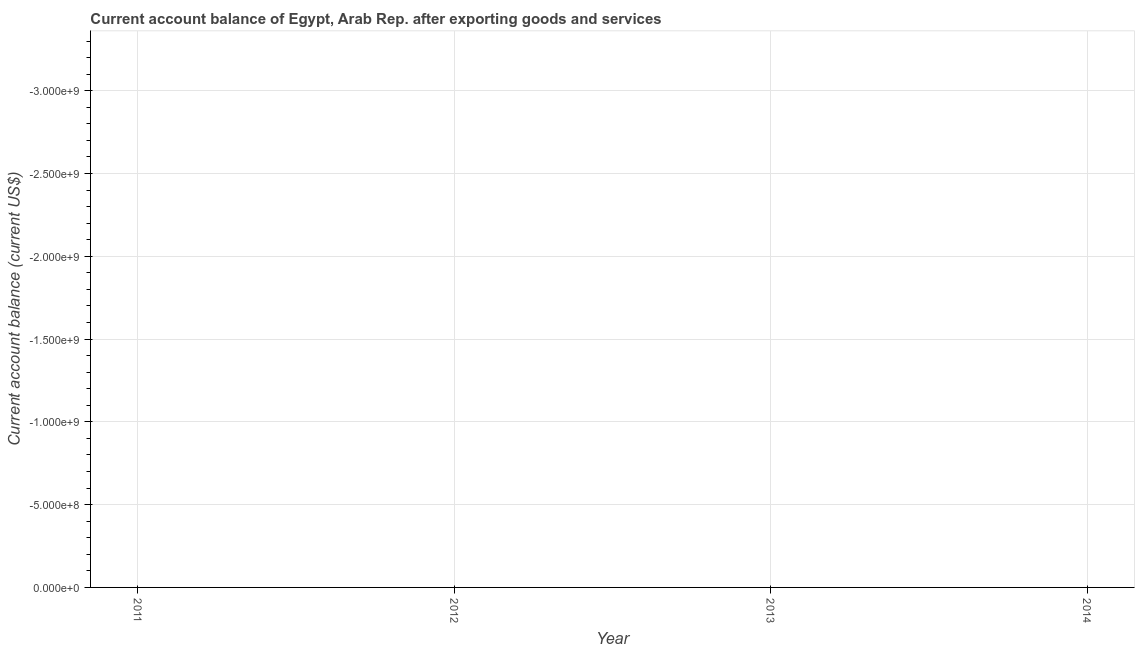Across all years, what is the minimum current account balance?
Keep it short and to the point. 0. In how many years, is the current account balance greater than -2700000000 US$?
Provide a short and direct response. 0. In how many years, is the current account balance greater than the average current account balance taken over all years?
Provide a short and direct response. 0. Does the current account balance monotonically increase over the years?
Offer a very short reply. No. How many years are there in the graph?
Your answer should be compact. 4. What is the difference between two consecutive major ticks on the Y-axis?
Provide a short and direct response. 5.00e+08. Does the graph contain grids?
Keep it short and to the point. Yes. What is the title of the graph?
Ensure brevity in your answer.  Current account balance of Egypt, Arab Rep. after exporting goods and services. What is the label or title of the Y-axis?
Provide a short and direct response. Current account balance (current US$). What is the Current account balance (current US$) in 2011?
Give a very brief answer. 0. What is the Current account balance (current US$) in 2012?
Ensure brevity in your answer.  0. What is the Current account balance (current US$) in 2014?
Ensure brevity in your answer.  0. 